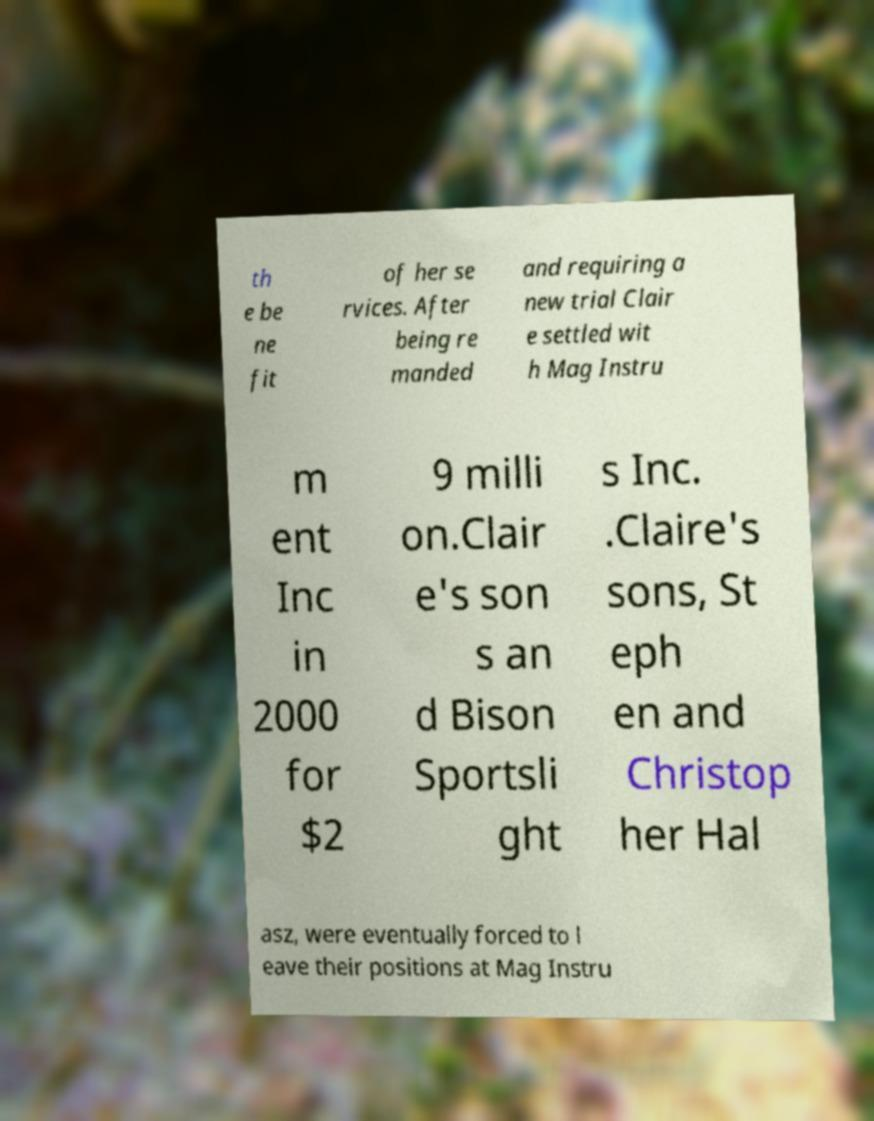Please identify and transcribe the text found in this image. th e be ne fit of her se rvices. After being re manded and requiring a new trial Clair e settled wit h Mag Instru m ent Inc in 2000 for $2 9 milli on.Clair e's son s an d Bison Sportsli ght s Inc. .Claire's sons, St eph en and Christop her Hal asz, were eventually forced to l eave their positions at Mag Instru 